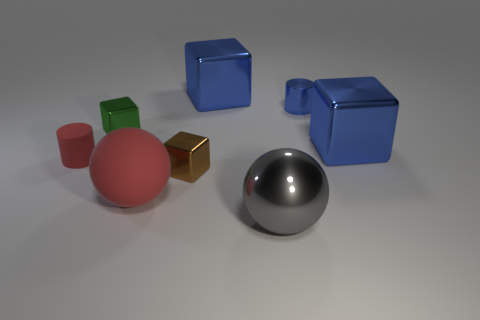There is a large thing that is the same color as the rubber cylinder; what is it made of?
Offer a very short reply. Rubber. Is the green block the same size as the gray shiny ball?
Offer a terse response. No. What number of things are either small brown metallic blocks or large gray balls?
Provide a succinct answer. 2. What shape is the large blue metal thing that is on the left side of the cube on the right side of the large metal thing in front of the brown metal block?
Your response must be concise. Cube. Is the material of the red object right of the small red cylinder the same as the small red object on the left side of the shiny cylinder?
Keep it short and to the point. Yes. What is the material of the other thing that is the same shape as the small blue object?
Provide a short and direct response. Rubber. Do the rubber object behind the red matte ball and the small blue metal thing behind the large gray sphere have the same shape?
Make the answer very short. Yes. Is the number of large blue shiny cubes that are in front of the small brown metal object less than the number of big blue shiny things behind the small green object?
Your answer should be very brief. Yes. How many other objects are the same shape as the big red rubber thing?
Make the answer very short. 1. There is a tiny brown thing that is made of the same material as the tiny green object; what shape is it?
Provide a short and direct response. Cube. 